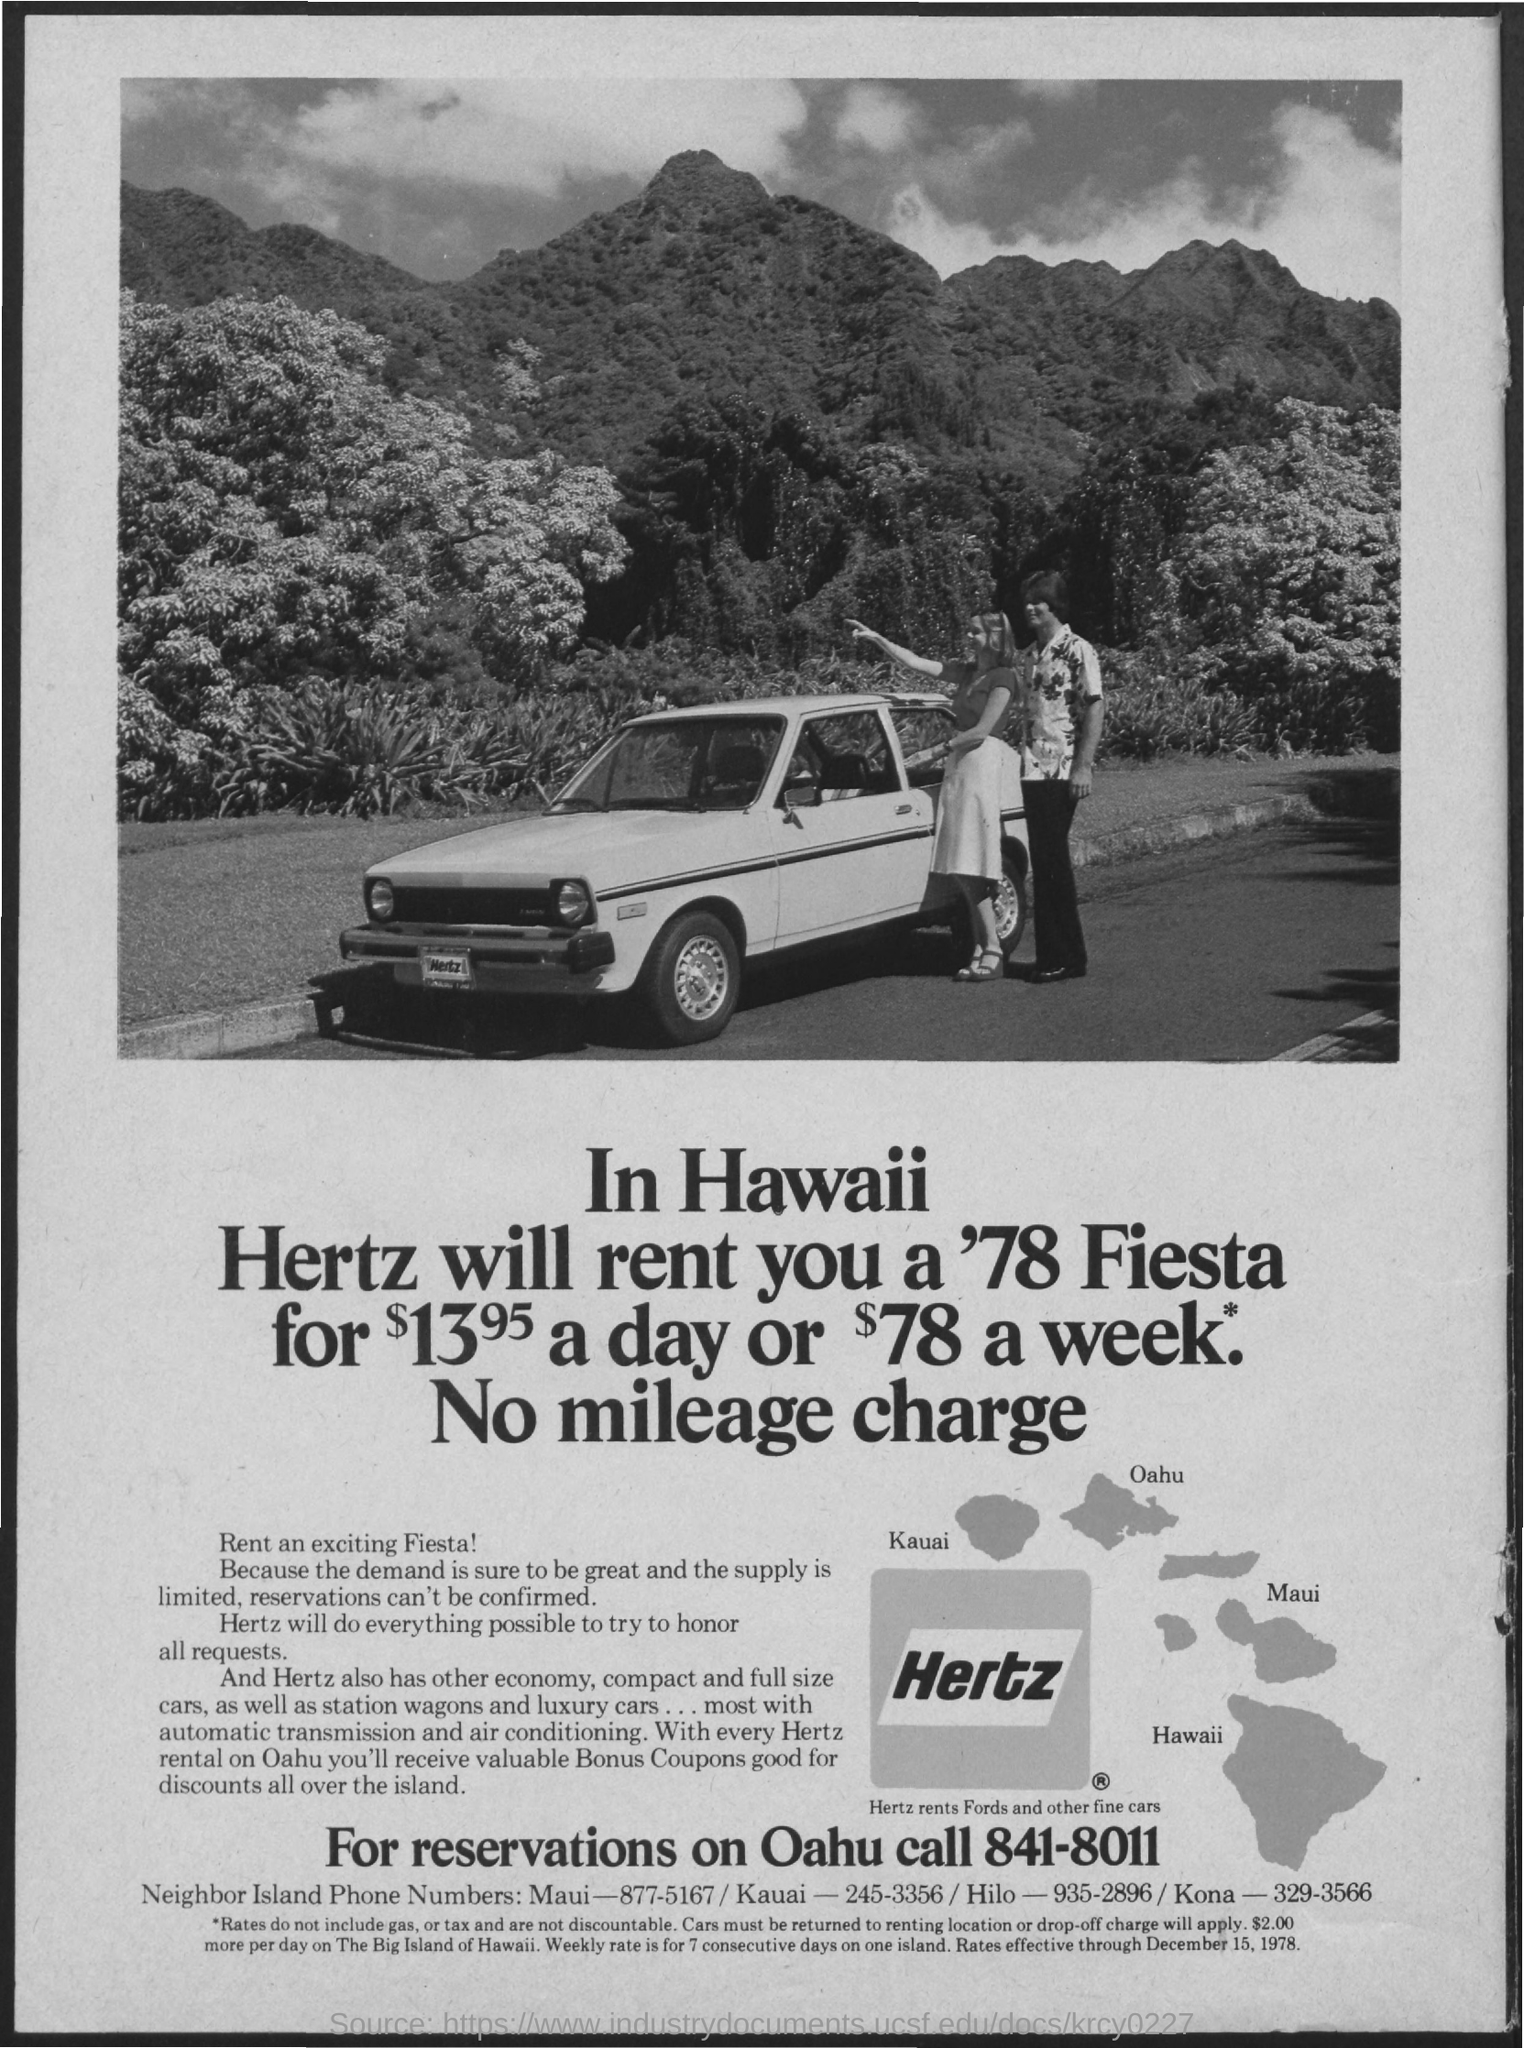Mention a couple of crucial points in this snapshot. To obtain the phone number for the neighbor island in Hilo, please dial 935-2896. The phone number for Maui is 877-5167. To obtain the phone number for the neighboring island from the Kona location, please dial 329-3566. To make a reservation on Oahu, please contact [841-8011]. To obtain the phone number for Neighbor Island Kauai, please dial 245-3356. 